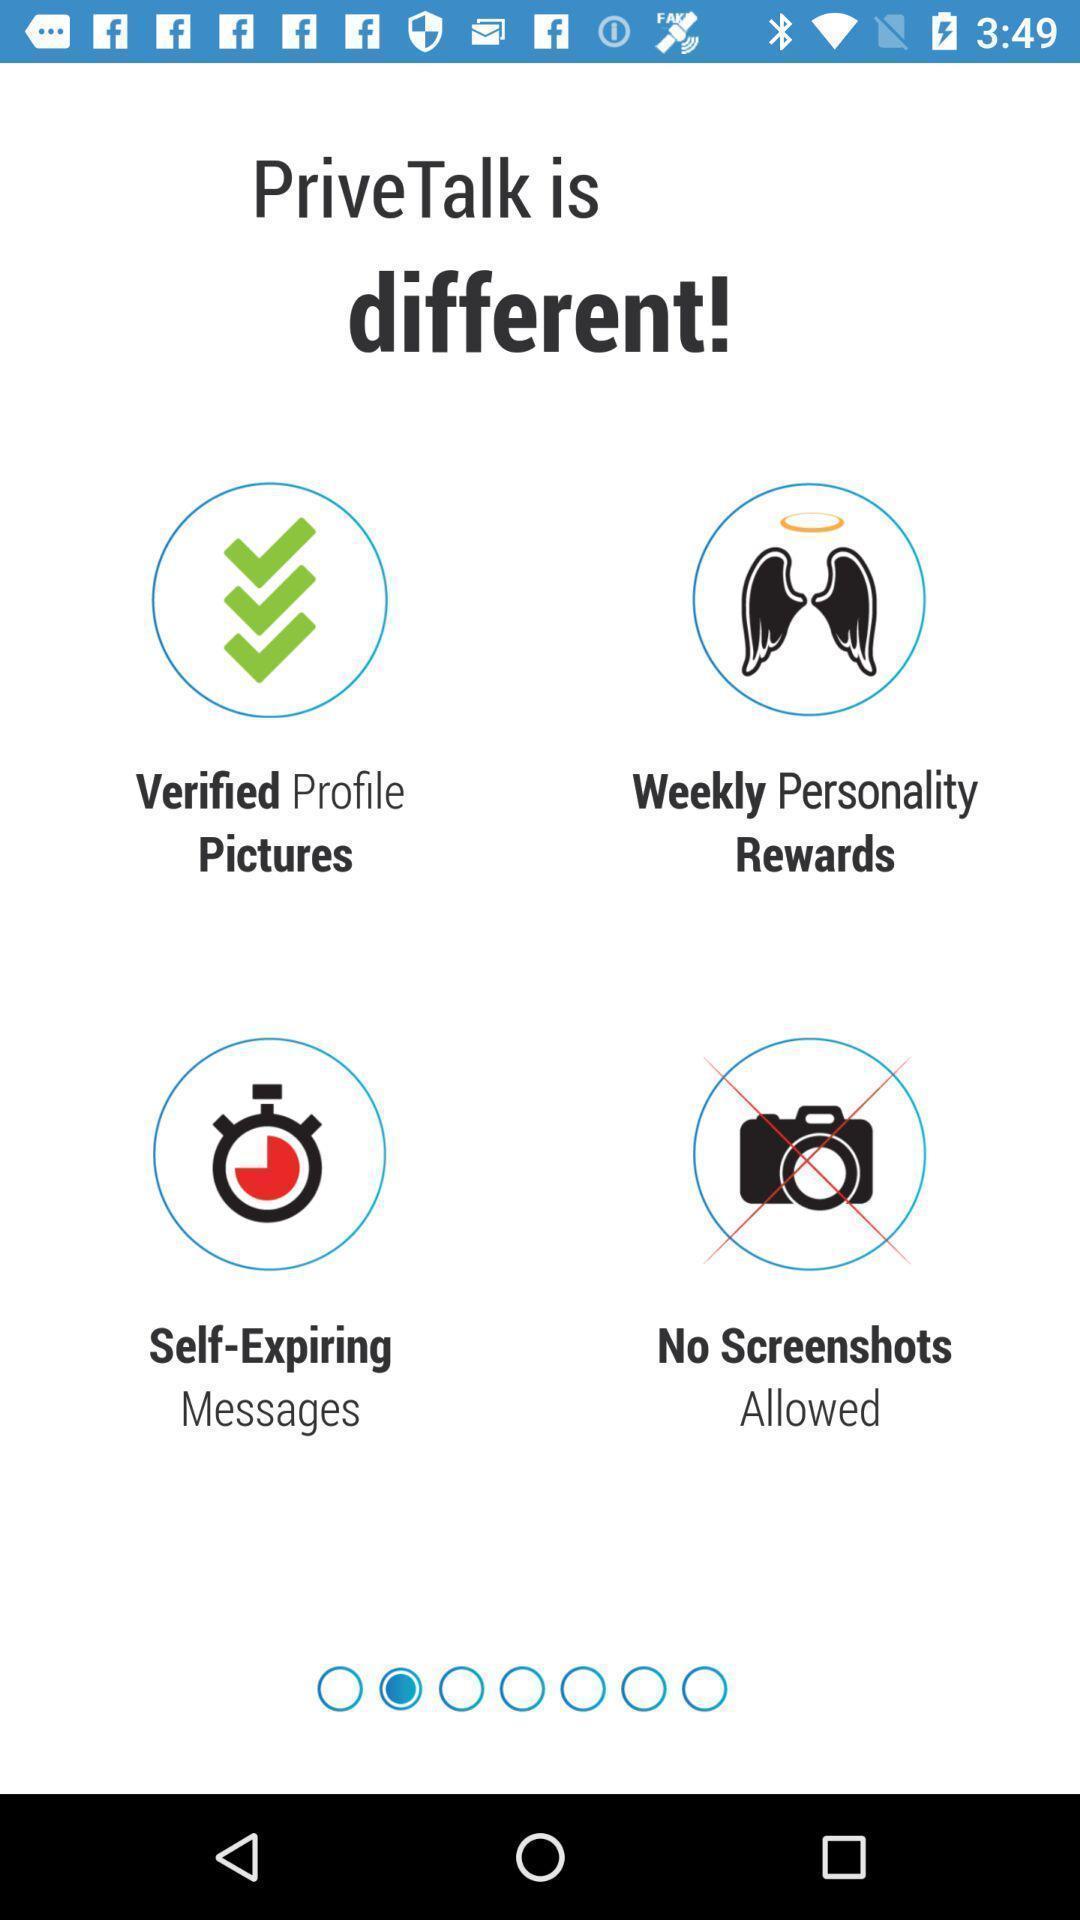Explain the elements present in this screenshot. Welcome page of a dating app. 